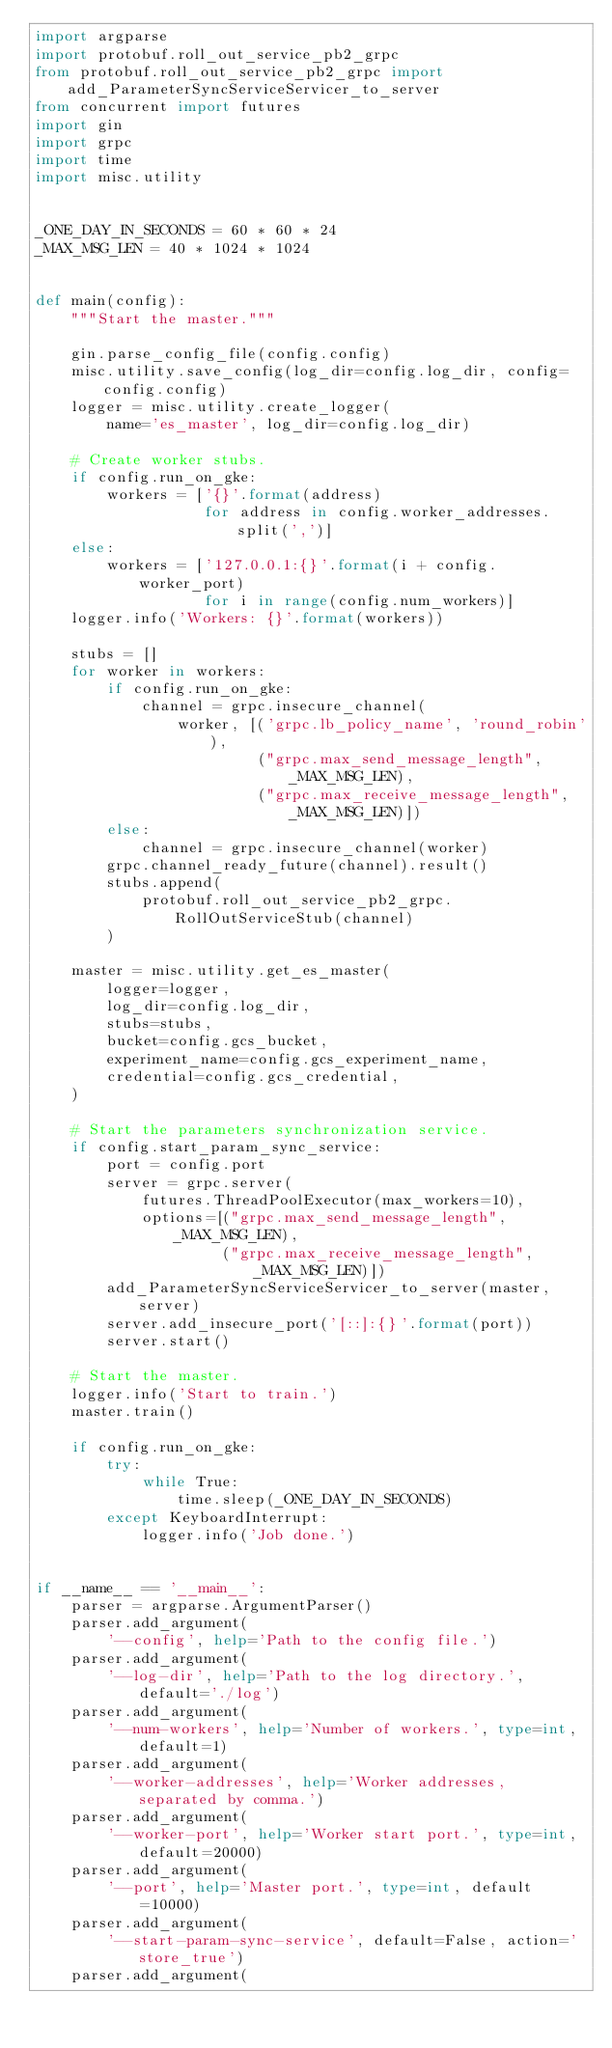<code> <loc_0><loc_0><loc_500><loc_500><_Python_>import argparse
import protobuf.roll_out_service_pb2_grpc
from protobuf.roll_out_service_pb2_grpc import add_ParameterSyncServiceServicer_to_server
from concurrent import futures
import gin
import grpc
import time
import misc.utility


_ONE_DAY_IN_SECONDS = 60 * 60 * 24
_MAX_MSG_LEN = 40 * 1024 * 1024


def main(config):
    """Start the master."""

    gin.parse_config_file(config.config)
    misc.utility.save_config(log_dir=config.log_dir, config=config.config)
    logger = misc.utility.create_logger(
        name='es_master', log_dir=config.log_dir)

    # Create worker stubs.
    if config.run_on_gke:
        workers = ['{}'.format(address)
                   for address in config.worker_addresses.split(',')]
    else:
        workers = ['127.0.0.1:{}'.format(i + config.worker_port)
                   for i in range(config.num_workers)]
    logger.info('Workers: {}'.format(workers))

    stubs = []
    for worker in workers:
        if config.run_on_gke:
            channel = grpc.insecure_channel(
                worker, [('grpc.lb_policy_name', 'round_robin'),
                         ("grpc.max_send_message_length", _MAX_MSG_LEN),
                         ("grpc.max_receive_message_length", _MAX_MSG_LEN)])
        else:
            channel = grpc.insecure_channel(worker)
        grpc.channel_ready_future(channel).result()
        stubs.append(
            protobuf.roll_out_service_pb2_grpc.RollOutServiceStub(channel)
        )

    master = misc.utility.get_es_master(
        logger=logger,
        log_dir=config.log_dir,
        stubs=stubs,
        bucket=config.gcs_bucket,
        experiment_name=config.gcs_experiment_name,
        credential=config.gcs_credential,
    )

    # Start the parameters synchronization service.
    if config.start_param_sync_service:
        port = config.port
        server = grpc.server(
            futures.ThreadPoolExecutor(max_workers=10),
            options=[("grpc.max_send_message_length", _MAX_MSG_LEN),
                     ("grpc.max_receive_message_length", _MAX_MSG_LEN)])
        add_ParameterSyncServiceServicer_to_server(master, server)
        server.add_insecure_port('[::]:{}'.format(port))
        server.start()

    # Start the master.
    logger.info('Start to train.')
    master.train()

    if config.run_on_gke:
        try:
            while True:
                time.sleep(_ONE_DAY_IN_SECONDS)
        except KeyboardInterrupt:
            logger.info('Job done.')


if __name__ == '__main__':
    parser = argparse.ArgumentParser()
    parser.add_argument(
        '--config', help='Path to the config file.')
    parser.add_argument(
        '--log-dir', help='Path to the log directory.', default='./log')
    parser.add_argument(
        '--num-workers', help='Number of workers.', type=int, default=1)
    parser.add_argument(
        '--worker-addresses', help='Worker addresses, separated by comma.')
    parser.add_argument(
        '--worker-port', help='Worker start port.', type=int, default=20000)
    parser.add_argument(
        '--port', help='Master port.', type=int, default=10000)
    parser.add_argument(
        '--start-param-sync-service', default=False, action='store_true')
    parser.add_argument(</code> 